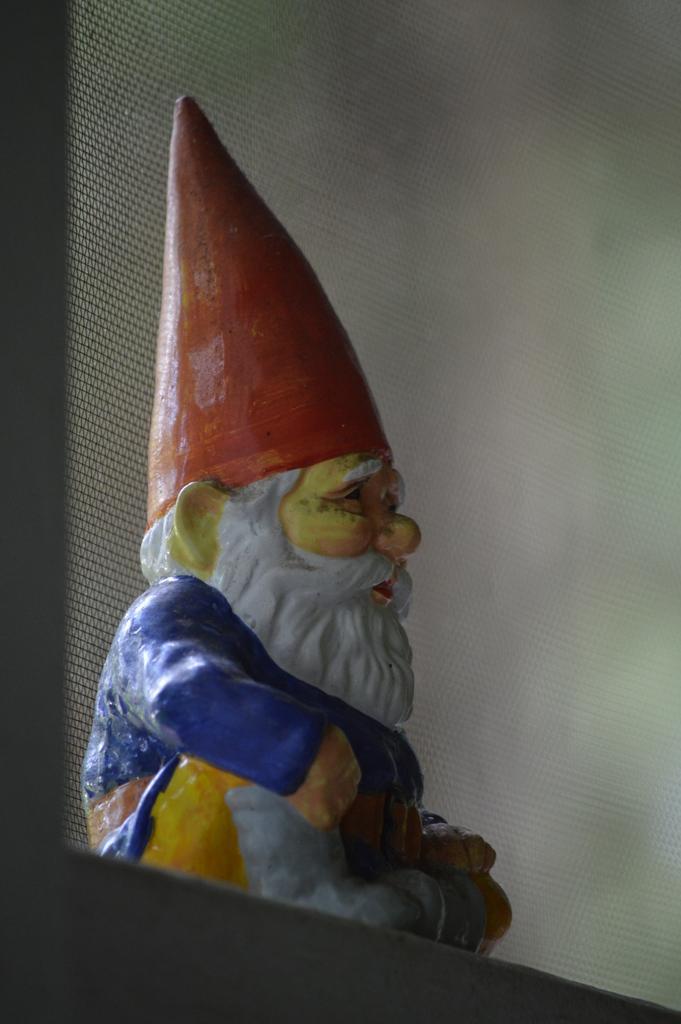Please provide a concise description of this image. In the center of the image, we can see a sculpture. 